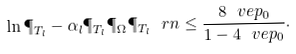Convert formula to latex. <formula><loc_0><loc_0><loc_500><loc_500>\ln \P _ { T _ { l } } - \alpha _ { l } \P _ { T _ { l } } \P _ { \Omega } \P _ { T _ { l } } \ r n \leq \frac { 8 \ v e p _ { 0 } } { 1 - 4 \ v e p _ { 0 } } .</formula> 